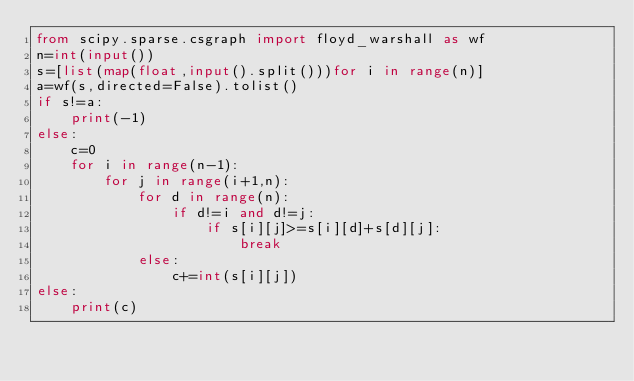Convert code to text. <code><loc_0><loc_0><loc_500><loc_500><_Python_>from scipy.sparse.csgraph import floyd_warshall as wf
n=int(input())
s=[list(map(float,input().split()))for i in range(n)]
a=wf(s,directed=False).tolist()
if s!=a:
    print(-1)
else:
    c=0
    for i in range(n-1):
        for j in range(i+1,n):
            for d in range(n):
                if d!=i and d!=j:
                    if s[i][j]>=s[i][d]+s[d][j]:
                        break
            else:
                c+=int(s[i][j])
else:
    print(c)</code> 